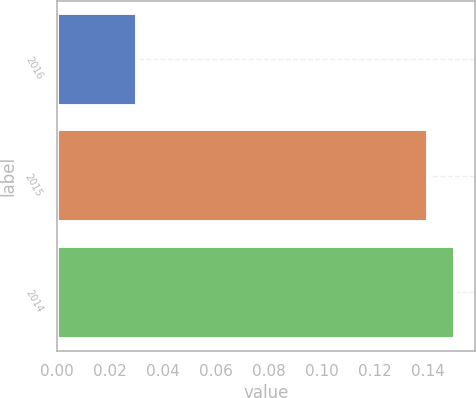Convert chart to OTSL. <chart><loc_0><loc_0><loc_500><loc_500><bar_chart><fcel>2016<fcel>2015<fcel>2014<nl><fcel>0.03<fcel>0.14<fcel>0.15<nl></chart> 